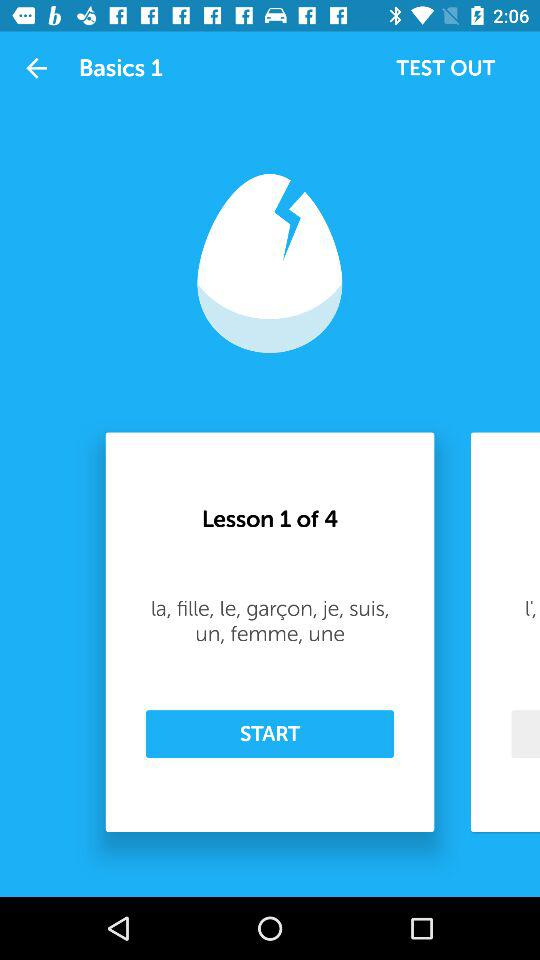At which lesson am I? You are at lesson 1. 